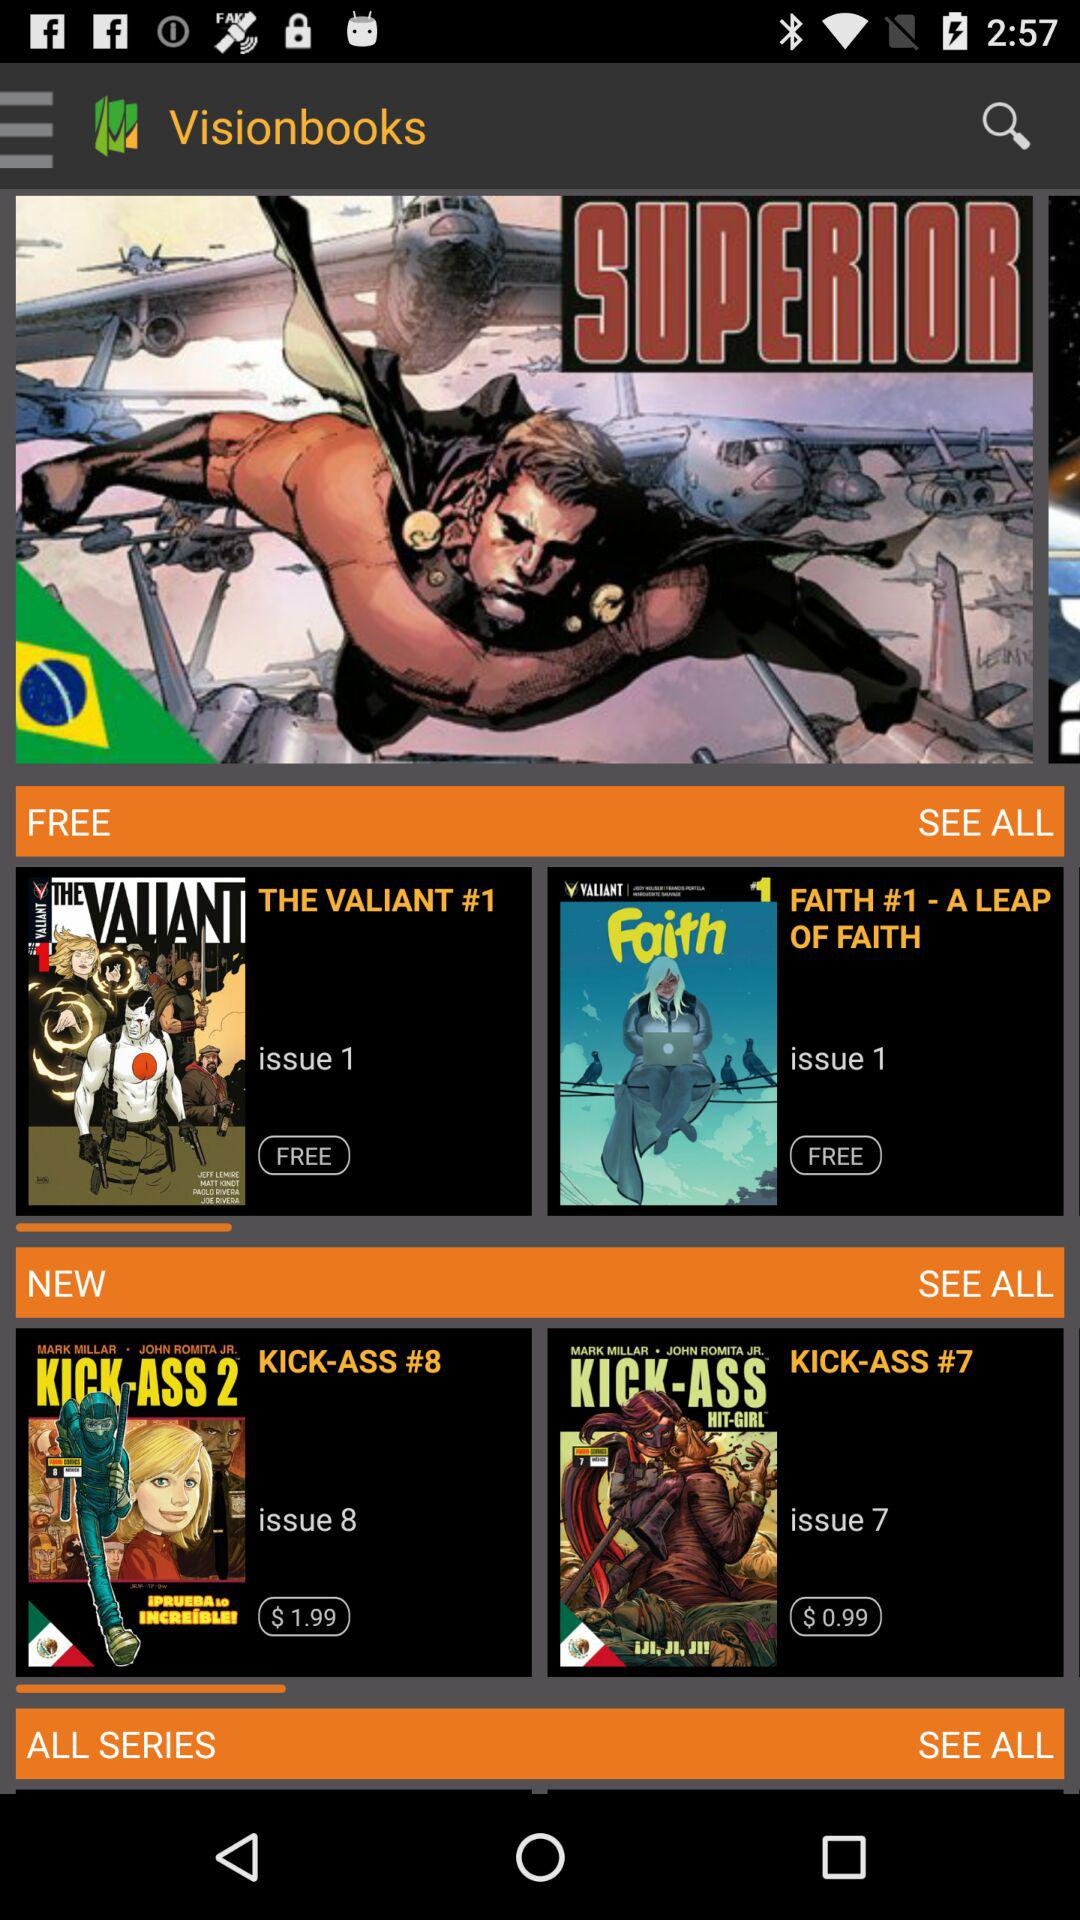How much does "KICK-ASS #8" cost? The cost is $1.99. 